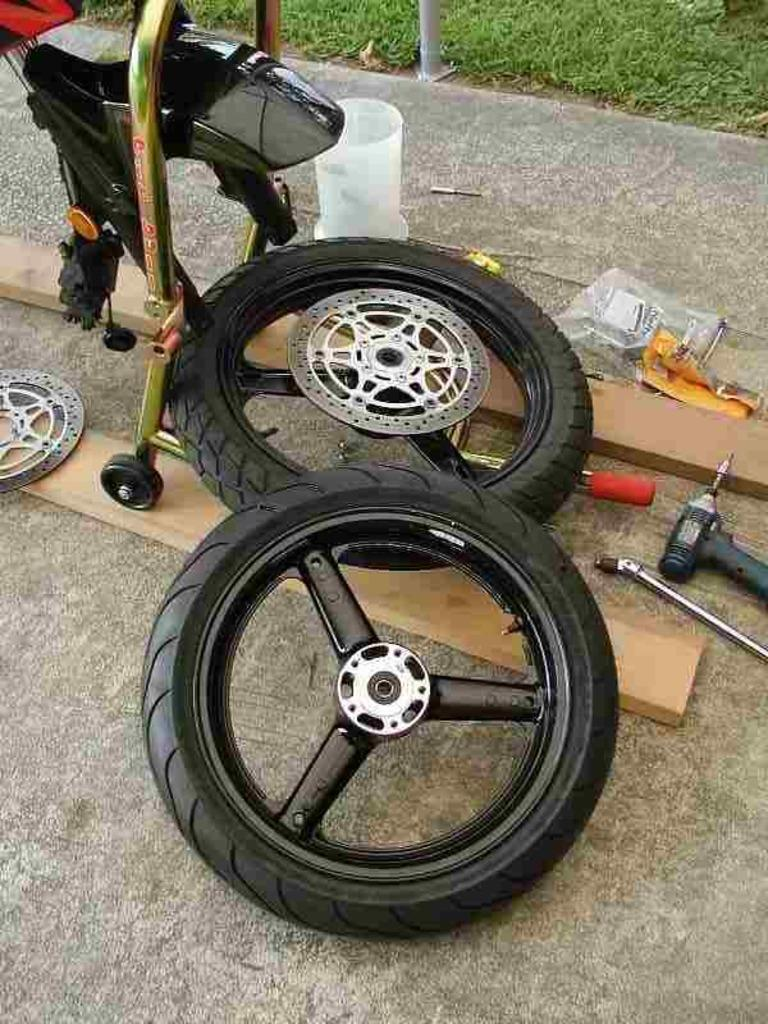What type of objects can be seen in the image? There are tyres, wooden planks, tools, and a polythene cover in the image. What might the wooden planks be used for? The wooden planks could be used for construction or as a base for the tyres. What is covering the objects in the image? There is a polythene cover in the image. What can be seen in the background of the image? There is grass visible in the background of the image. What type of education is being provided in the image? There is no indication of education being provided in the image; it features objects such as tyres, wooden planks, tools, and a polythene cover. How many ducks are visible in the image? There are no ducks present in the image. 